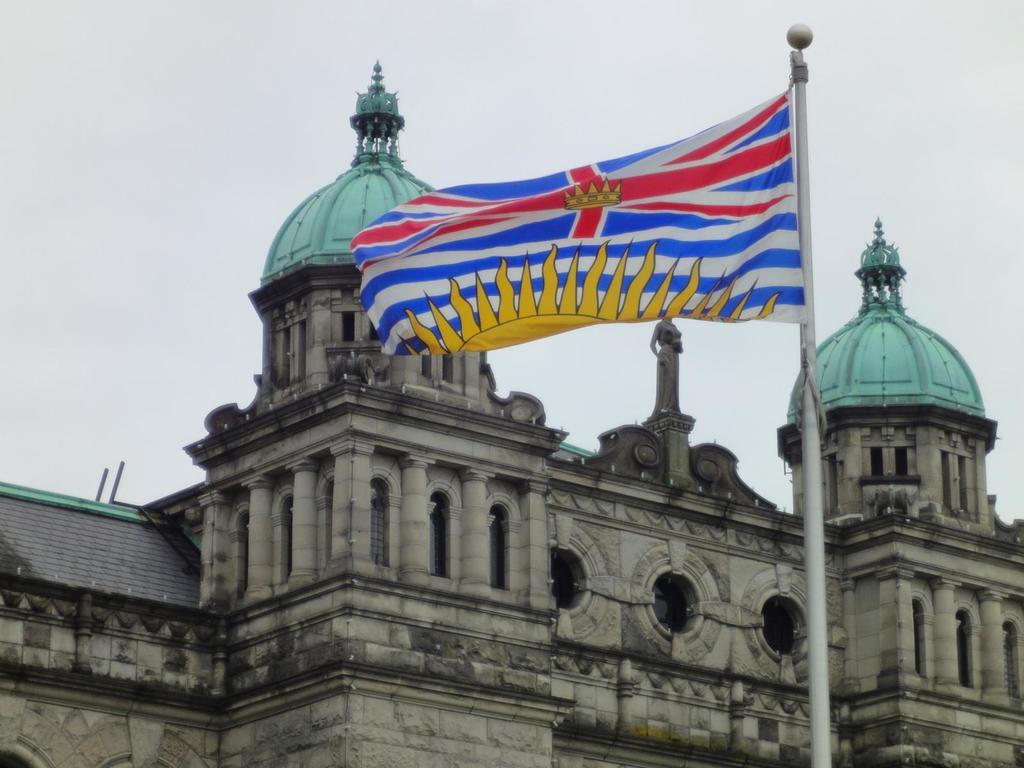What is the main structure in the image? There is a building in the image. What is located near the building? There is a statue near the building. What can be seen flying in the image? There is a flag in the image. What is visible in the background of the image? The sky is visible in the background of the image. What type of wound can be seen on the statue in the image? There is no wound present on the statue in the image. What type of spacecraft can be seen in the image? There is no spacecraft present in the image. 